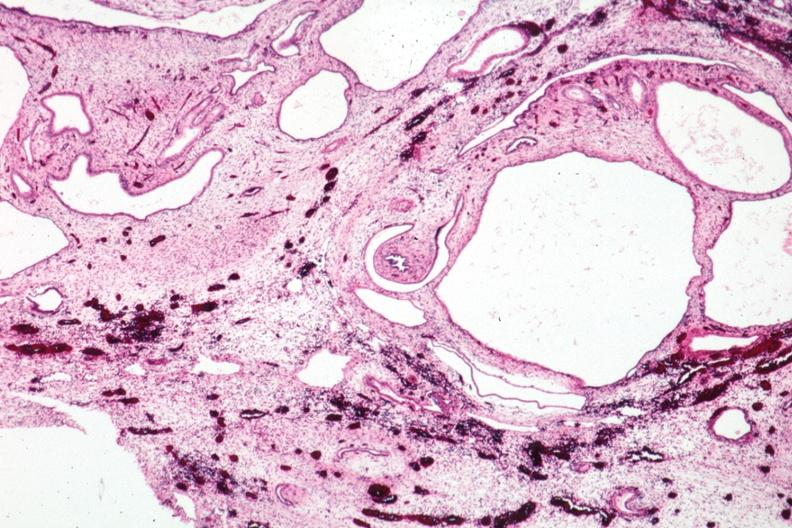s polycystic disease infant present?
Answer the question using a single word or phrase. Yes 